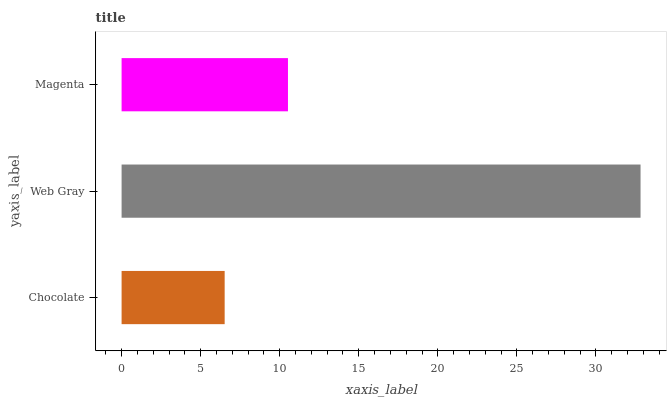Is Chocolate the minimum?
Answer yes or no. Yes. Is Web Gray the maximum?
Answer yes or no. Yes. Is Magenta the minimum?
Answer yes or no. No. Is Magenta the maximum?
Answer yes or no. No. Is Web Gray greater than Magenta?
Answer yes or no. Yes. Is Magenta less than Web Gray?
Answer yes or no. Yes. Is Magenta greater than Web Gray?
Answer yes or no. No. Is Web Gray less than Magenta?
Answer yes or no. No. Is Magenta the high median?
Answer yes or no. Yes. Is Magenta the low median?
Answer yes or no. Yes. Is Web Gray the high median?
Answer yes or no. No. Is Chocolate the low median?
Answer yes or no. No. 